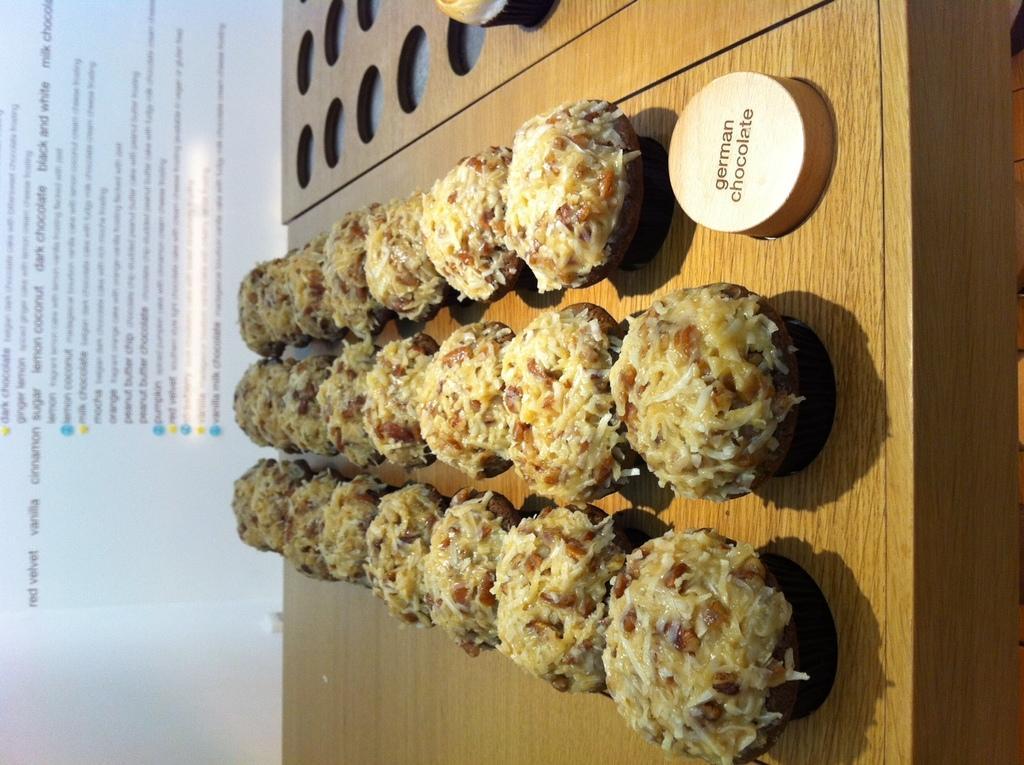How would you summarize this image in a sentence or two? In this image we can see some food which are placed on the table. We can also see a piece of wood with some text on it. On the backside we can see some text. 